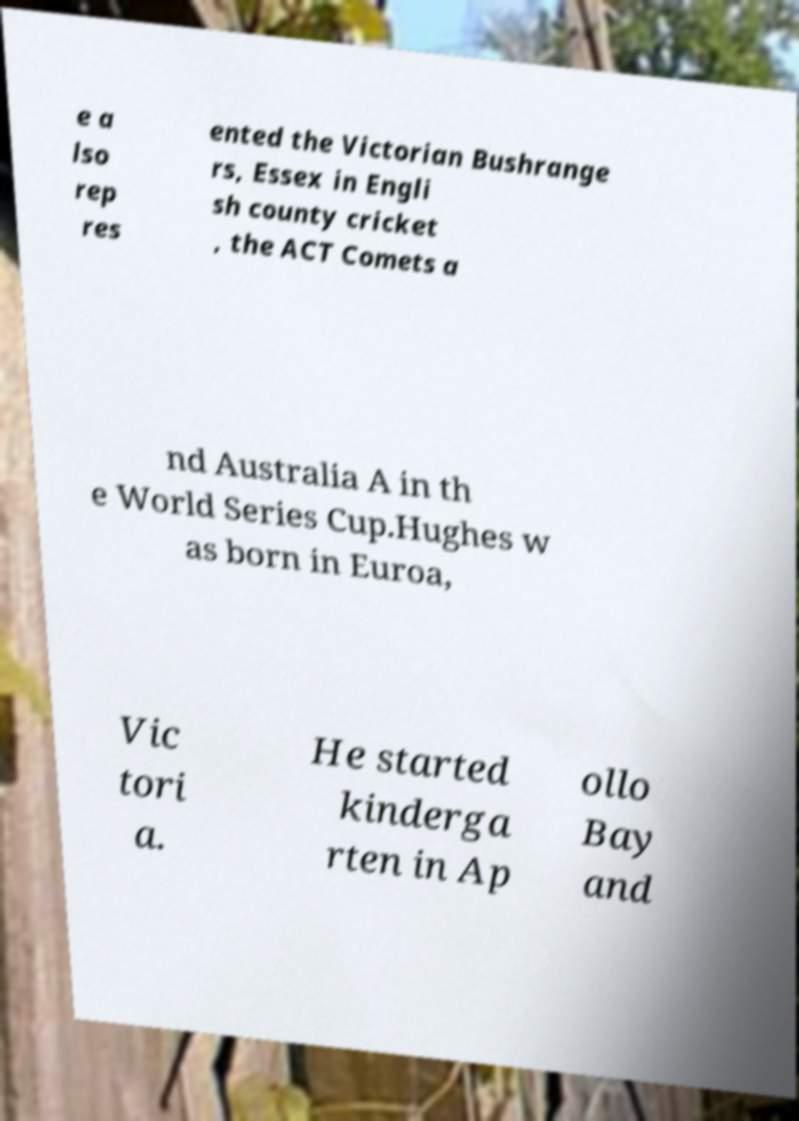Please identify and transcribe the text found in this image. e a lso rep res ented the Victorian Bushrange rs, Essex in Engli sh county cricket , the ACT Comets a nd Australia A in th e World Series Cup.Hughes w as born in Euroa, Vic tori a. He started kinderga rten in Ap ollo Bay and 